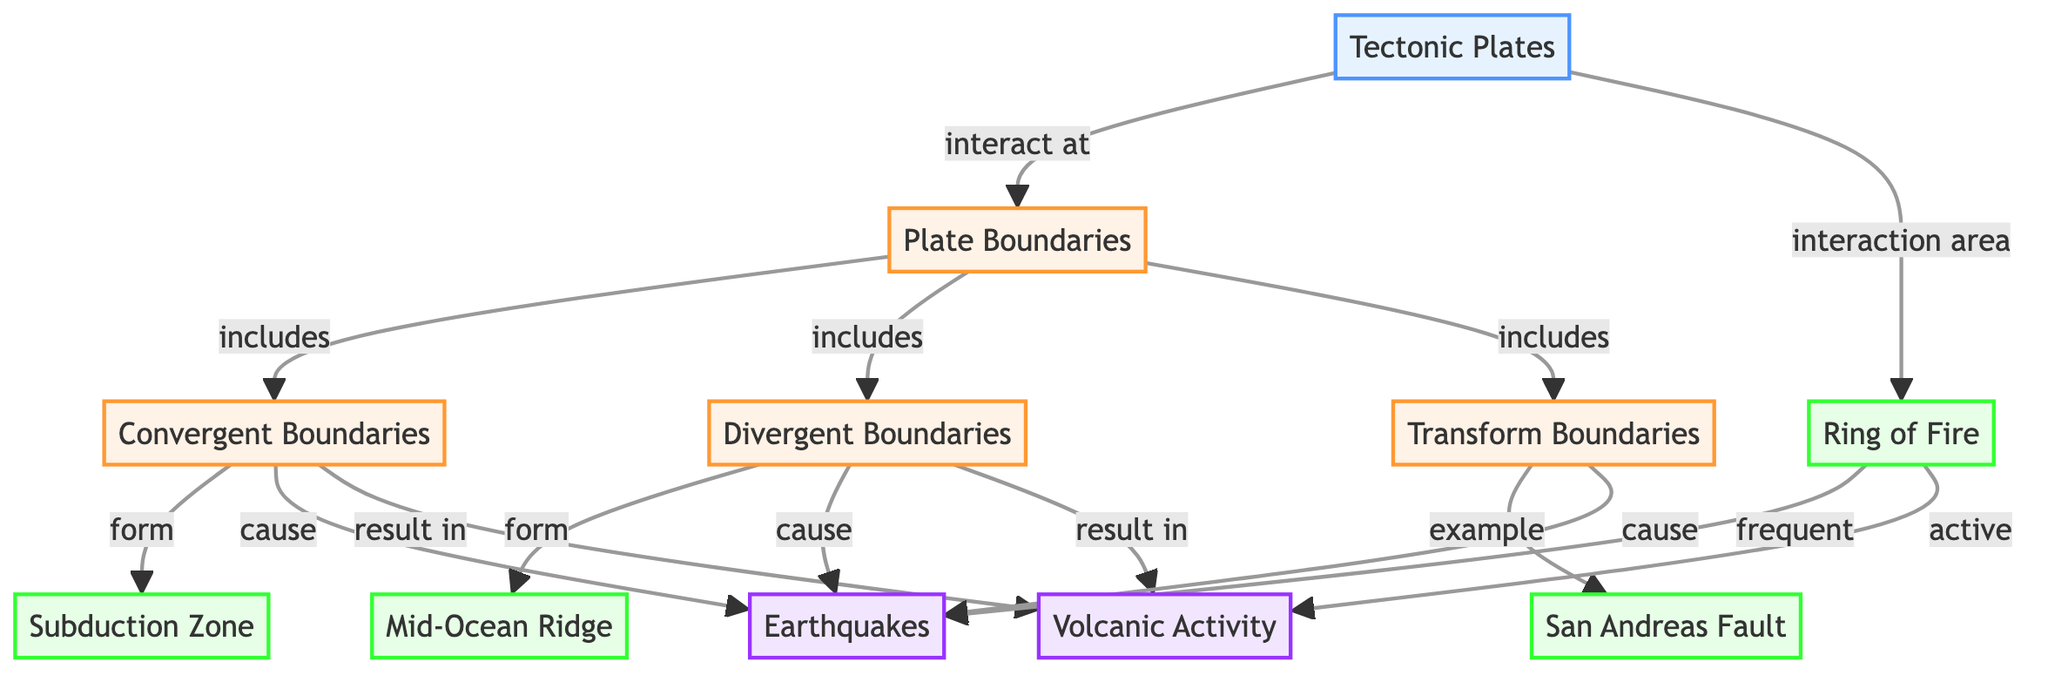what are the three types of plate boundaries mentioned in the diagram? The diagram indicates three types of plate boundaries: convergent boundaries, divergent boundaries, and transform boundaries, which are clearly labeled and categorized under the plate boundaries node.
Answer: convergent, divergent, transform which natural phenomena are caused by convergent boundaries? The diagram specifies that earthquakes and volcanic activity result from convergent boundaries, showing a direct connection from convergent boundaries to these phenomena.
Answer: earthquakes, volcanic activity how does the ring of fire relate to earthquakes and volcanic activity? The ring of fire is described as having frequent earthquakes and being active in volcanic activity, illustrating the connection between tectonic activity in this area and the phenomena listed.
Answer: frequent earthquakes, active volcanic activity what type of boundary forms a subduction zone? According to the diagram, a subduction zone is formed by convergent boundaries, indicating a direct link between these two concepts.
Answer: convergent boundaries which example of a transform boundary is mentioned in the diagram? The San Andreas Fault is listed as an example of a transform boundary in the diagram, clearly identified under the transform boundaries section.
Answer: San Andreas Fault how many phenomena are linked to divergent boundaries? The diagram connects two phenomena to divergent boundaries: earthquakes and volcanic activity, counted directly from the links in that section.
Answer: two what is the relationship between tectonic plates and the ring of fire? The diagram illustrates that tectonic plates interact in the area known as the ring of fire, showing it as a junction for tectonic activity.
Answer: interaction area which phenomenon is most frequently associated with the ring of fire? The diagram emphasizes that earthquakes are frequent in the ring of fire, which is highlighted as a key characteristic of this region's tectonic activity.
Answer: earthquakes 